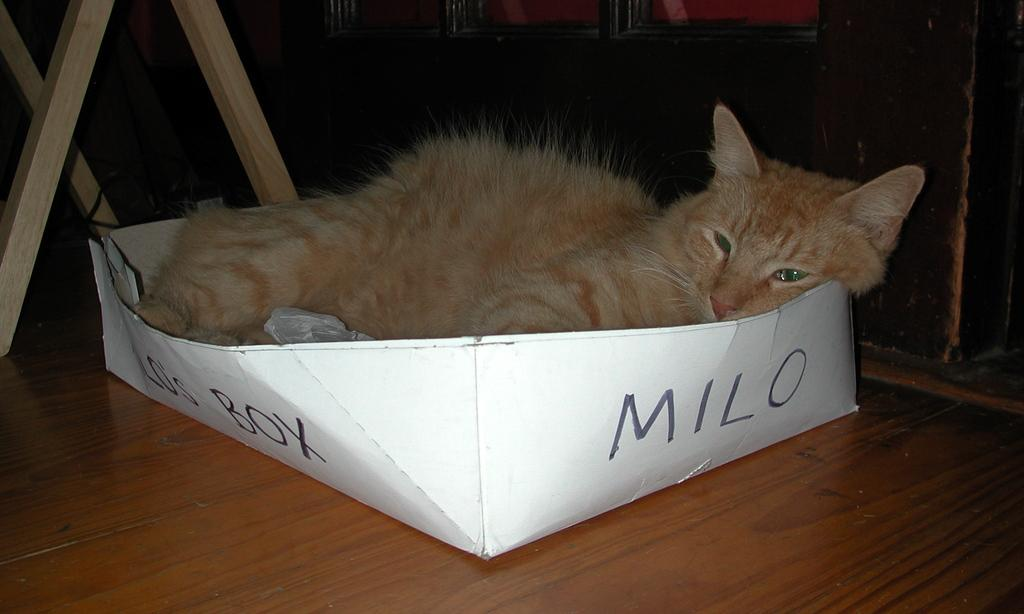What color is the box in the image? The box in the image is white-colored. What type of animal can be seen in the image? There is a cream-colored cat in the image. What is written on the box? There is writing on the box. What color are the objects in the background of the image? The objects in the background of the image are cream-colored. What type of music is the cat playing in the image? There is no music or indication of the cat playing music in the image. How many bushes are visible in the background of the image? There are no bushes visible in the image; only cream-colored objects are present in the background. 